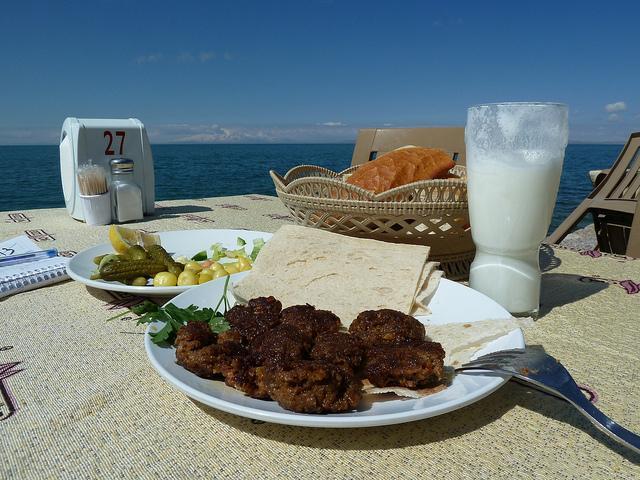Why would someone be seated here?
Choose the correct response and explain in the format: 'Answer: answer
Rationale: rationale.'
Options: To eat, to work, to paint, to wait. Answer: to eat.
Rationale: Someone would want to seat here to eat food. 